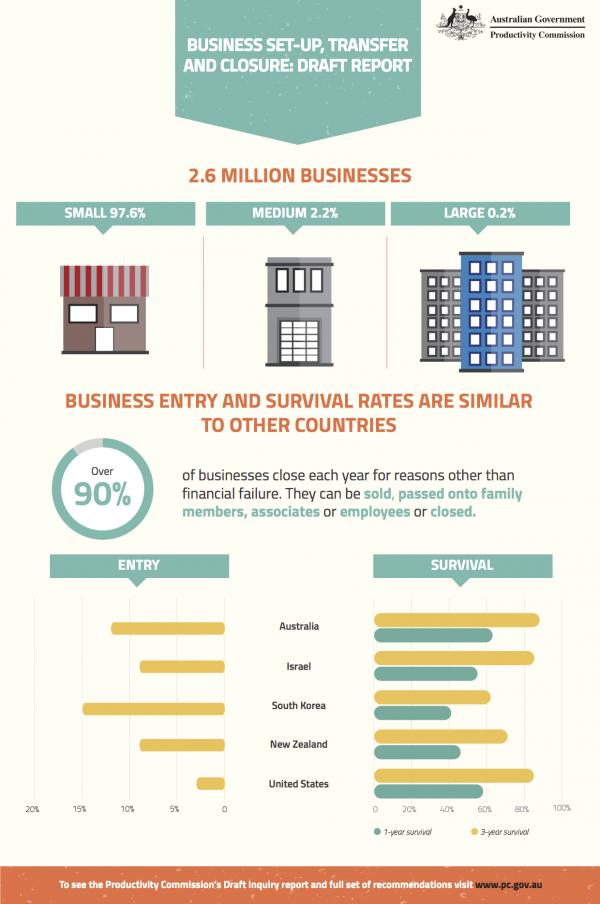Outline some significant characteristics in this image. The United States has a business entry rate that is less than 5%. The graph shows the survival rates of countries, and the question is asking how many countries have survival rates above 80%. New Zealand has the second lowest 1-year survival rate among the countries shown in the graph. According to the data, Australia has a 1-year survival rate above 60%. According to recent statistics, the 1-year survival rate of Australia is significantly higher than the 3-year survival rate of South Korea. 